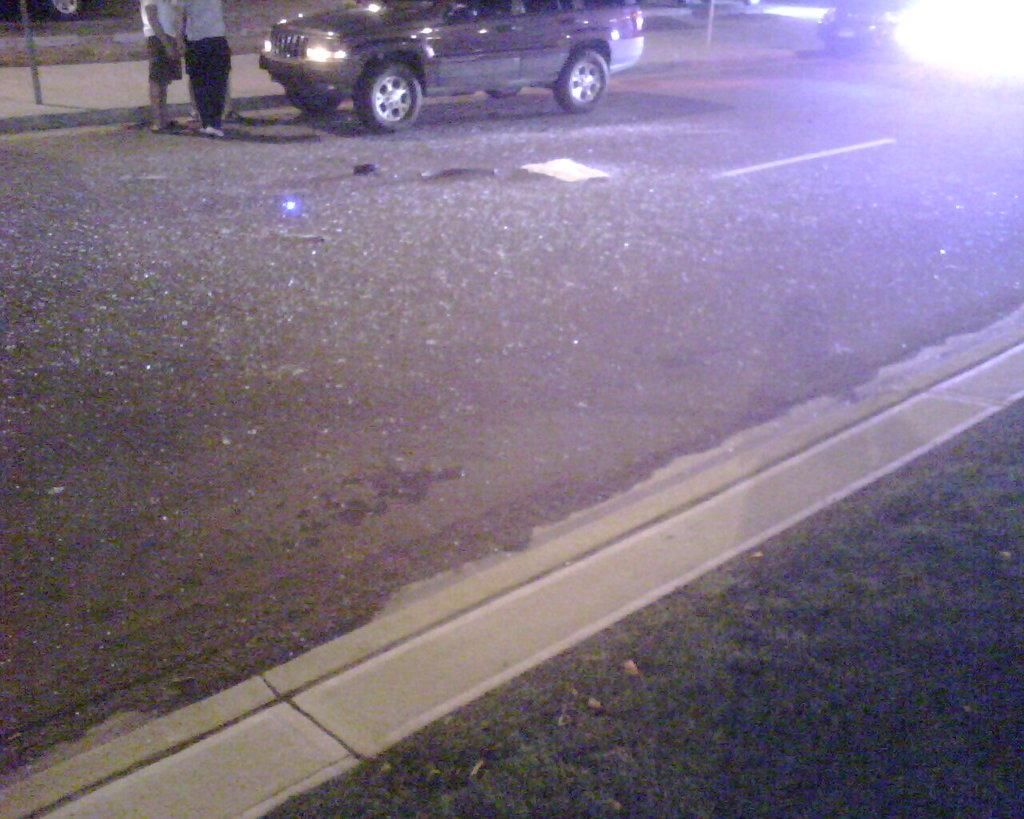What is the main subject of the image? The main subject of the image is a car. Can you describe the people in the image? There are two persons on the road in the image. What else can be seen in the image besides the car and people? There are poles in the image. What type of natural environment is visible in the image? Grass is visible at the bottom of the image. What type of quarter can be seen in the image? There is no quarter present in the image. What does the voice of the person in the image sound like? The image does not provide any information about the person's voice. 